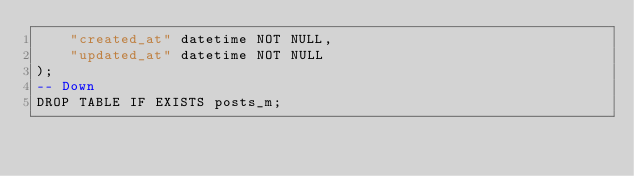Convert code to text. <code><loc_0><loc_0><loc_500><loc_500><_SQL_>    "created_at" datetime NOT NULL,
    "updated_at" datetime NOT NULL
);
-- Down
DROP TABLE IF EXISTS posts_m;</code> 